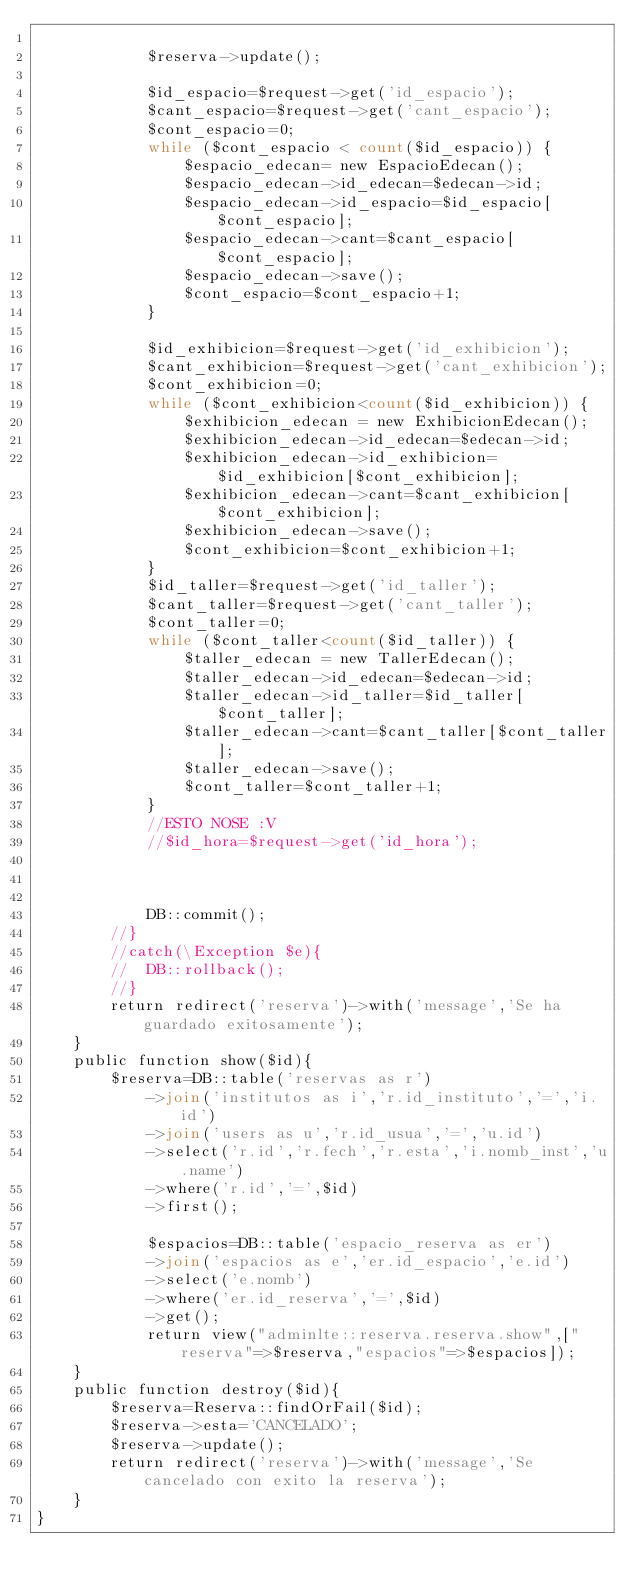<code> <loc_0><loc_0><loc_500><loc_500><_PHP_>
            $reserva->update();

    		$id_espacio=$request->get('id_espacio');
    		$cant_espacio=$request->get('cant_espacio');
    		$cont_espacio=0;
    		while ($cont_espacio < count($id_espacio)) {
    			$espacio_edecan= new EspacioEdecan();
    			$espacio_edecan->id_edecan=$edecan->id;
    			$espacio_edecan->id_espacio=$id_espacio[$cont_espacio];
    			$espacio_edecan->cant=$cant_espacio[$cont_espacio];
    			$espacio_edecan->save();
    			$cont_espacio=$cont_espacio+1;
    		}

    		$id_exhibicion=$request->get('id_exhibicion');
    		$cant_exhibicion=$request->get('cant_exhibicion');
    		$cont_exhibicion=0;
    		while ($cont_exhibicion<count($id_exhibicion)) {
    			$exhibicion_edecan = new ExhibicionEdecan();
    			$exhibicion_edecan->id_edecan=$edecan->id;
    			$exhibicion_edecan->id_exhibicion=$id_exhibicion[$cont_exhibicion];
    			$exhibicion_edecan->cant=$cant_exhibicion[$cont_exhibicion];
    			$exhibicion_edecan->save();
    			$cont_exhibicion=$cont_exhibicion+1;
    		}
    		$id_taller=$request->get('id_taller');
    		$cant_taller=$request->get('cant_taller');
    		$cont_taller=0;
    		while ($cont_taller<count($id_taller)) {
    			$taller_edecan = new TallerEdecan();
    			$taller_edecan->id_edecan=$edecan->id;
    			$taller_edecan->id_taller=$id_taller[$cont_taller];
    			$taller_edecan->cant=$cant_taller[$cont_taller];
    			$taller_edecan->save();
    			$cont_taller=$cont_taller+1;
    		}
    		//ESTO NOSE :V
    		//$id_hora=$request->get('id_hora');



    		DB::commit();
    	//}
    	//catch(\Exception $e){
    	//	DB::rollback();
    	//}
    	return redirect('reserva')->with('message','Se ha guardado exitosamente');
    }
    public function show($id){
    	$reserva=DB::table('reservas as r')
    		->join('institutos as i','r.id_instituto','=','i.id')
    		->join('users as u','r.id_usua','=','u.id')
    		->select('r.id','r.fech','r.esta','i.nomb_inst','u.name')
    		->where('r.id','=',$id)
    		->first();

    		$espacios=DB::table('espacio_reserva as er')
    		->join('espacios as e','er.id_espacio','e.id')
    		->select('e.nomb')
    		->where('er.id_reserva','=',$id)
    		->get();
    		return view("adminlte::reserva.reserva.show",["reserva"=>$reserva,"espacios"=>$espacios]);
    }
    public function destroy($id){
    	$reserva=Reserva::findOrFail($id);
    	$reserva->esta='CANCELADO';
    	$reserva->update();
    	return redirect('reserva')->with('message','Se cancelado con exito la reserva');
    }
}
</code> 